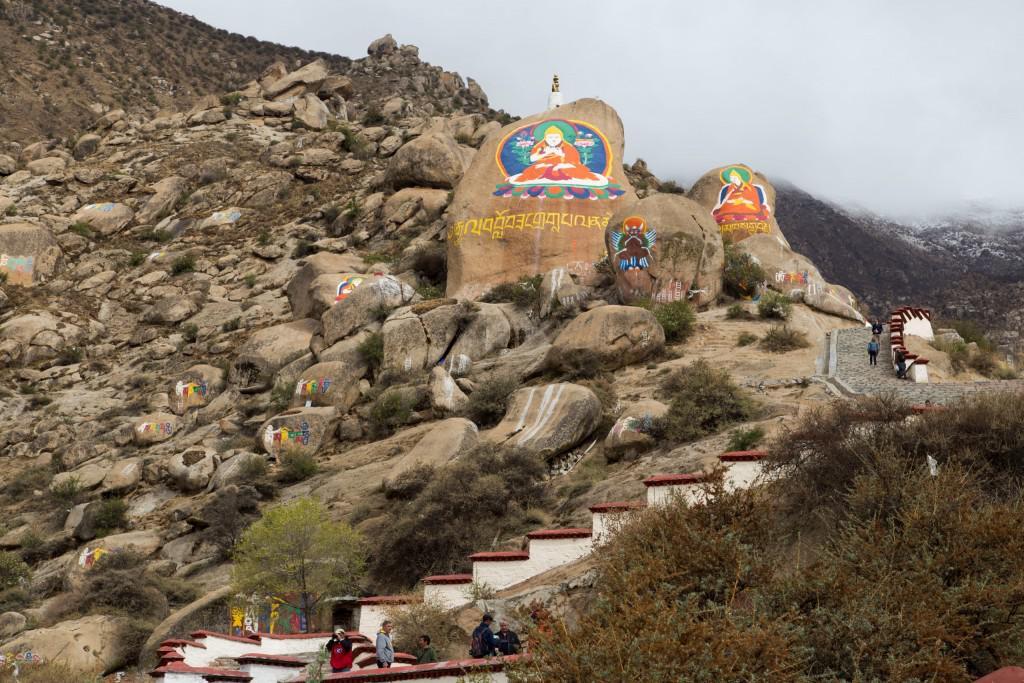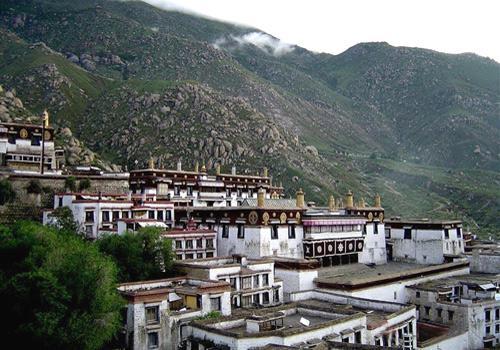The first image is the image on the left, the second image is the image on the right. Evaluate the accuracy of this statement regarding the images: "There are a set of red brick topped buildings sitting on the edge of a cliff.". Is it true? Answer yes or no. No. The first image is the image on the left, the second image is the image on the right. For the images shown, is this caption "We see at least one mansion, built onto a skinny cliff; there certainly isn't enough room for a town." true? Answer yes or no. No. 